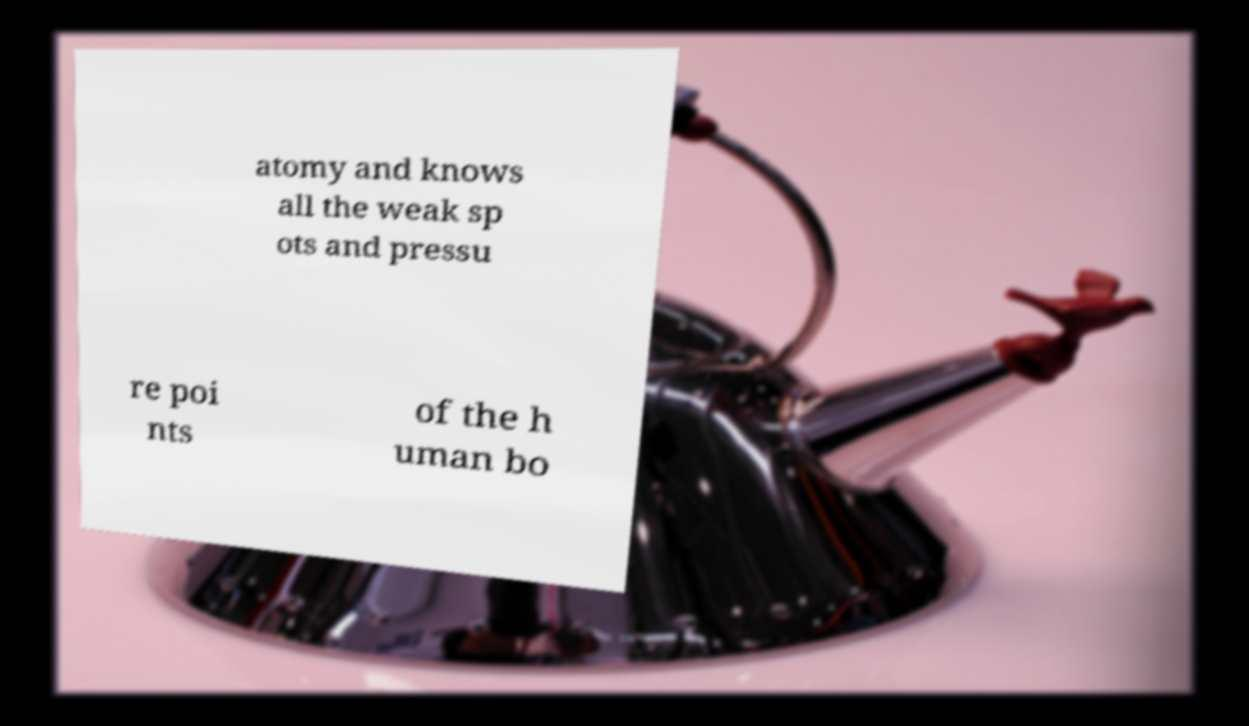For documentation purposes, I need the text within this image transcribed. Could you provide that? atomy and knows all the weak sp ots and pressu re poi nts of the h uman bo 